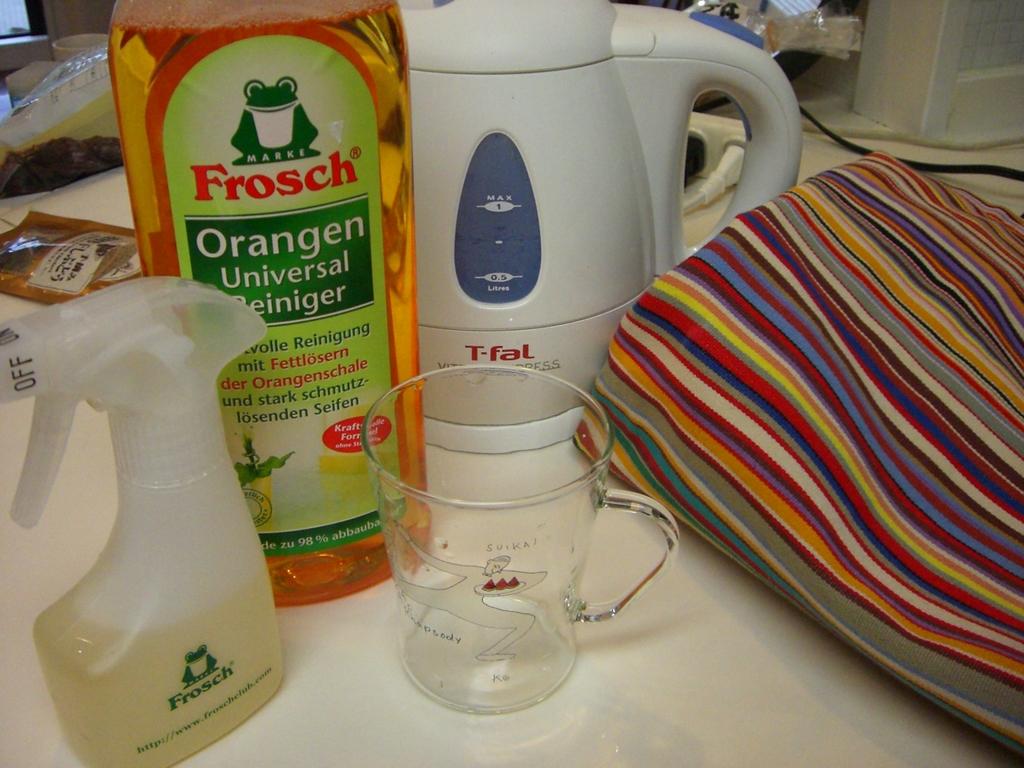What is the brand of orange cleaning liquid?
Provide a succinct answer. Frosch. What is the brand of the white kettle?
Your answer should be compact. T-fal. 